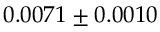<formula> <loc_0><loc_0><loc_500><loc_500>0 . 0 0 7 1 \pm 0 . 0 0 1 0</formula> 